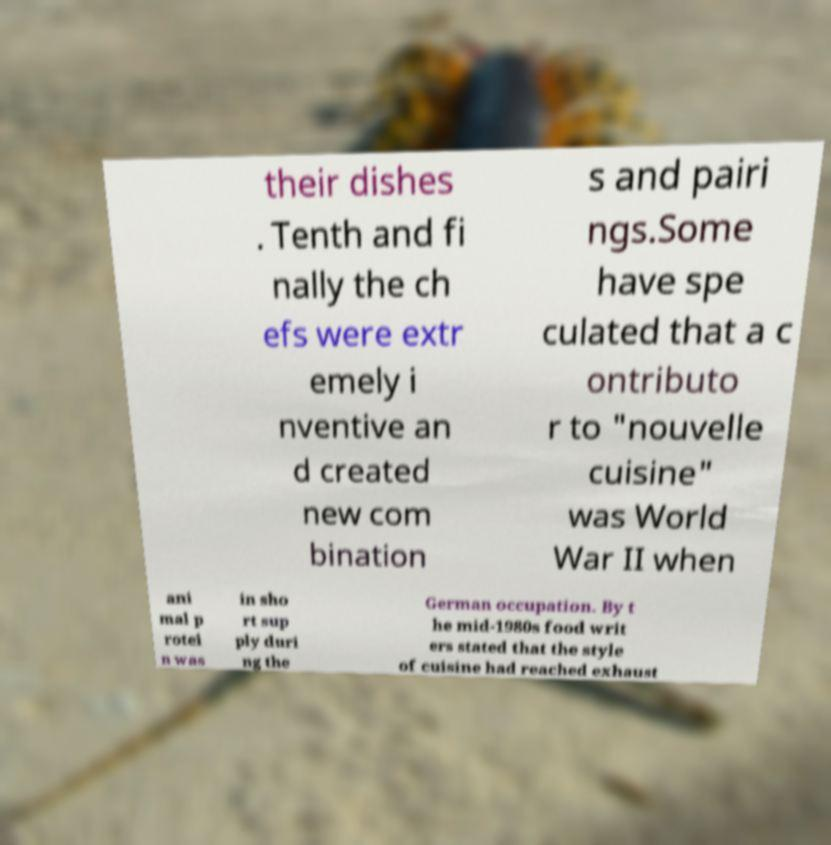Can you accurately transcribe the text from the provided image for me? their dishes . Tenth and fi nally the ch efs were extr emely i nventive an d created new com bination s and pairi ngs.Some have spe culated that a c ontributo r to "nouvelle cuisine" was World War II when ani mal p rotei n was in sho rt sup ply duri ng the German occupation. By t he mid-1980s food writ ers stated that the style of cuisine had reached exhaust 